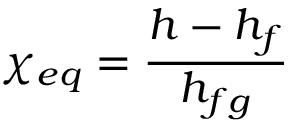Convert formula to latex. <formula><loc_0><loc_0><loc_500><loc_500>\chi _ { e q } = { \frac { h - h _ { f } } { h _ { f g } } }</formula> 